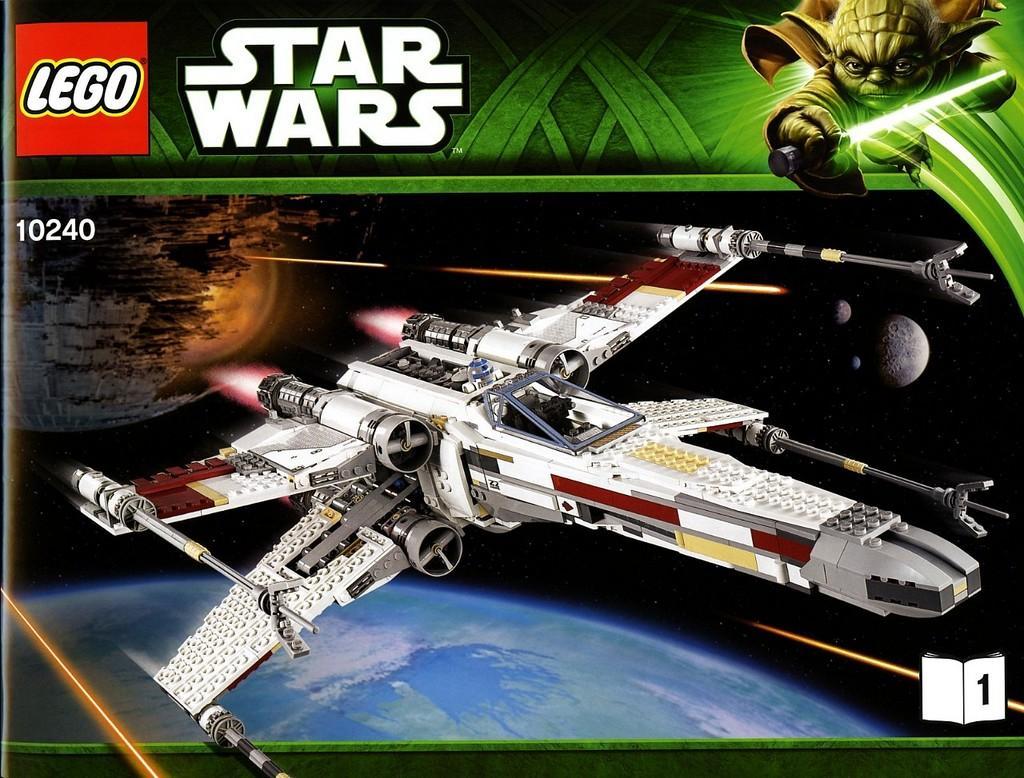How would you summarize this image in a sentence or two? It is an edited image, there is a plane and around that plane there are some images and logos. It is written as "STAR WARS" above the image. 